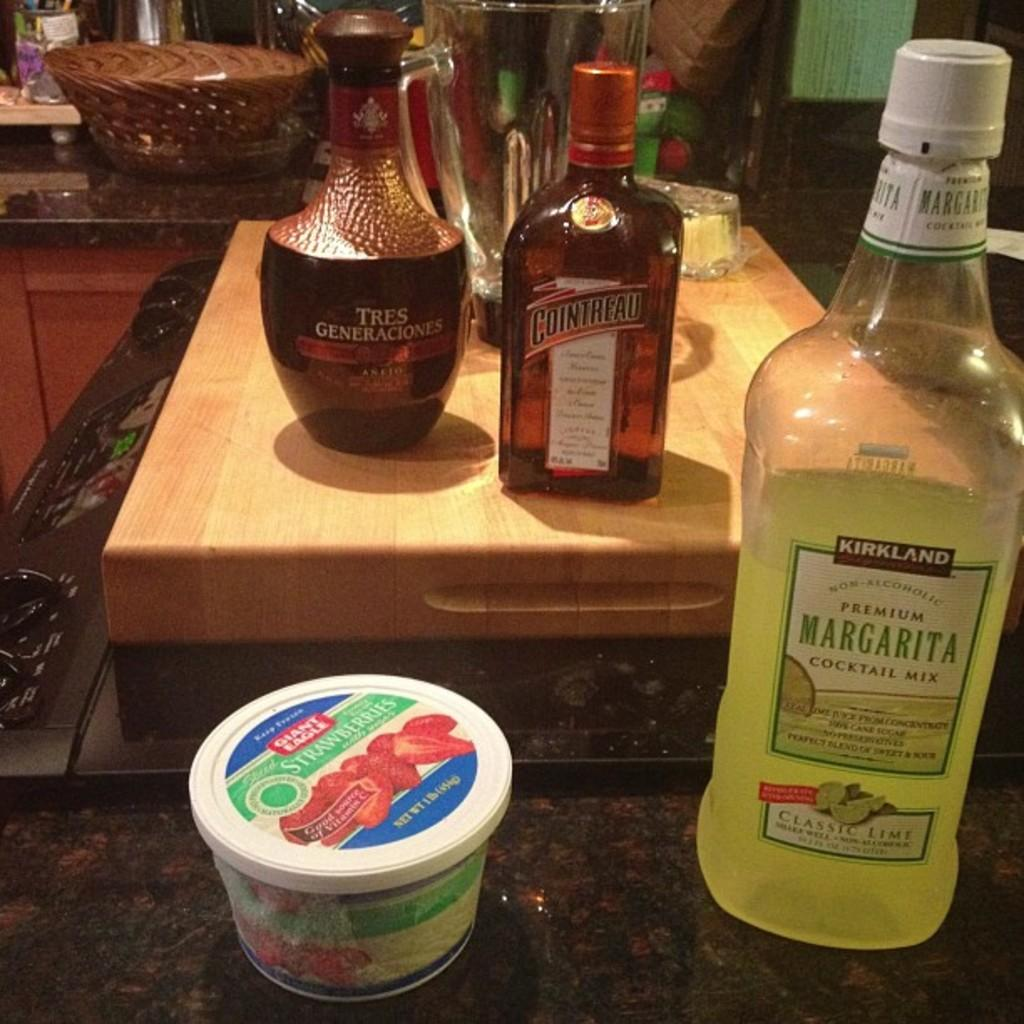<image>
Relay a brief, clear account of the picture shown. bottles of liquor on a kitchen counter include Cointreau 